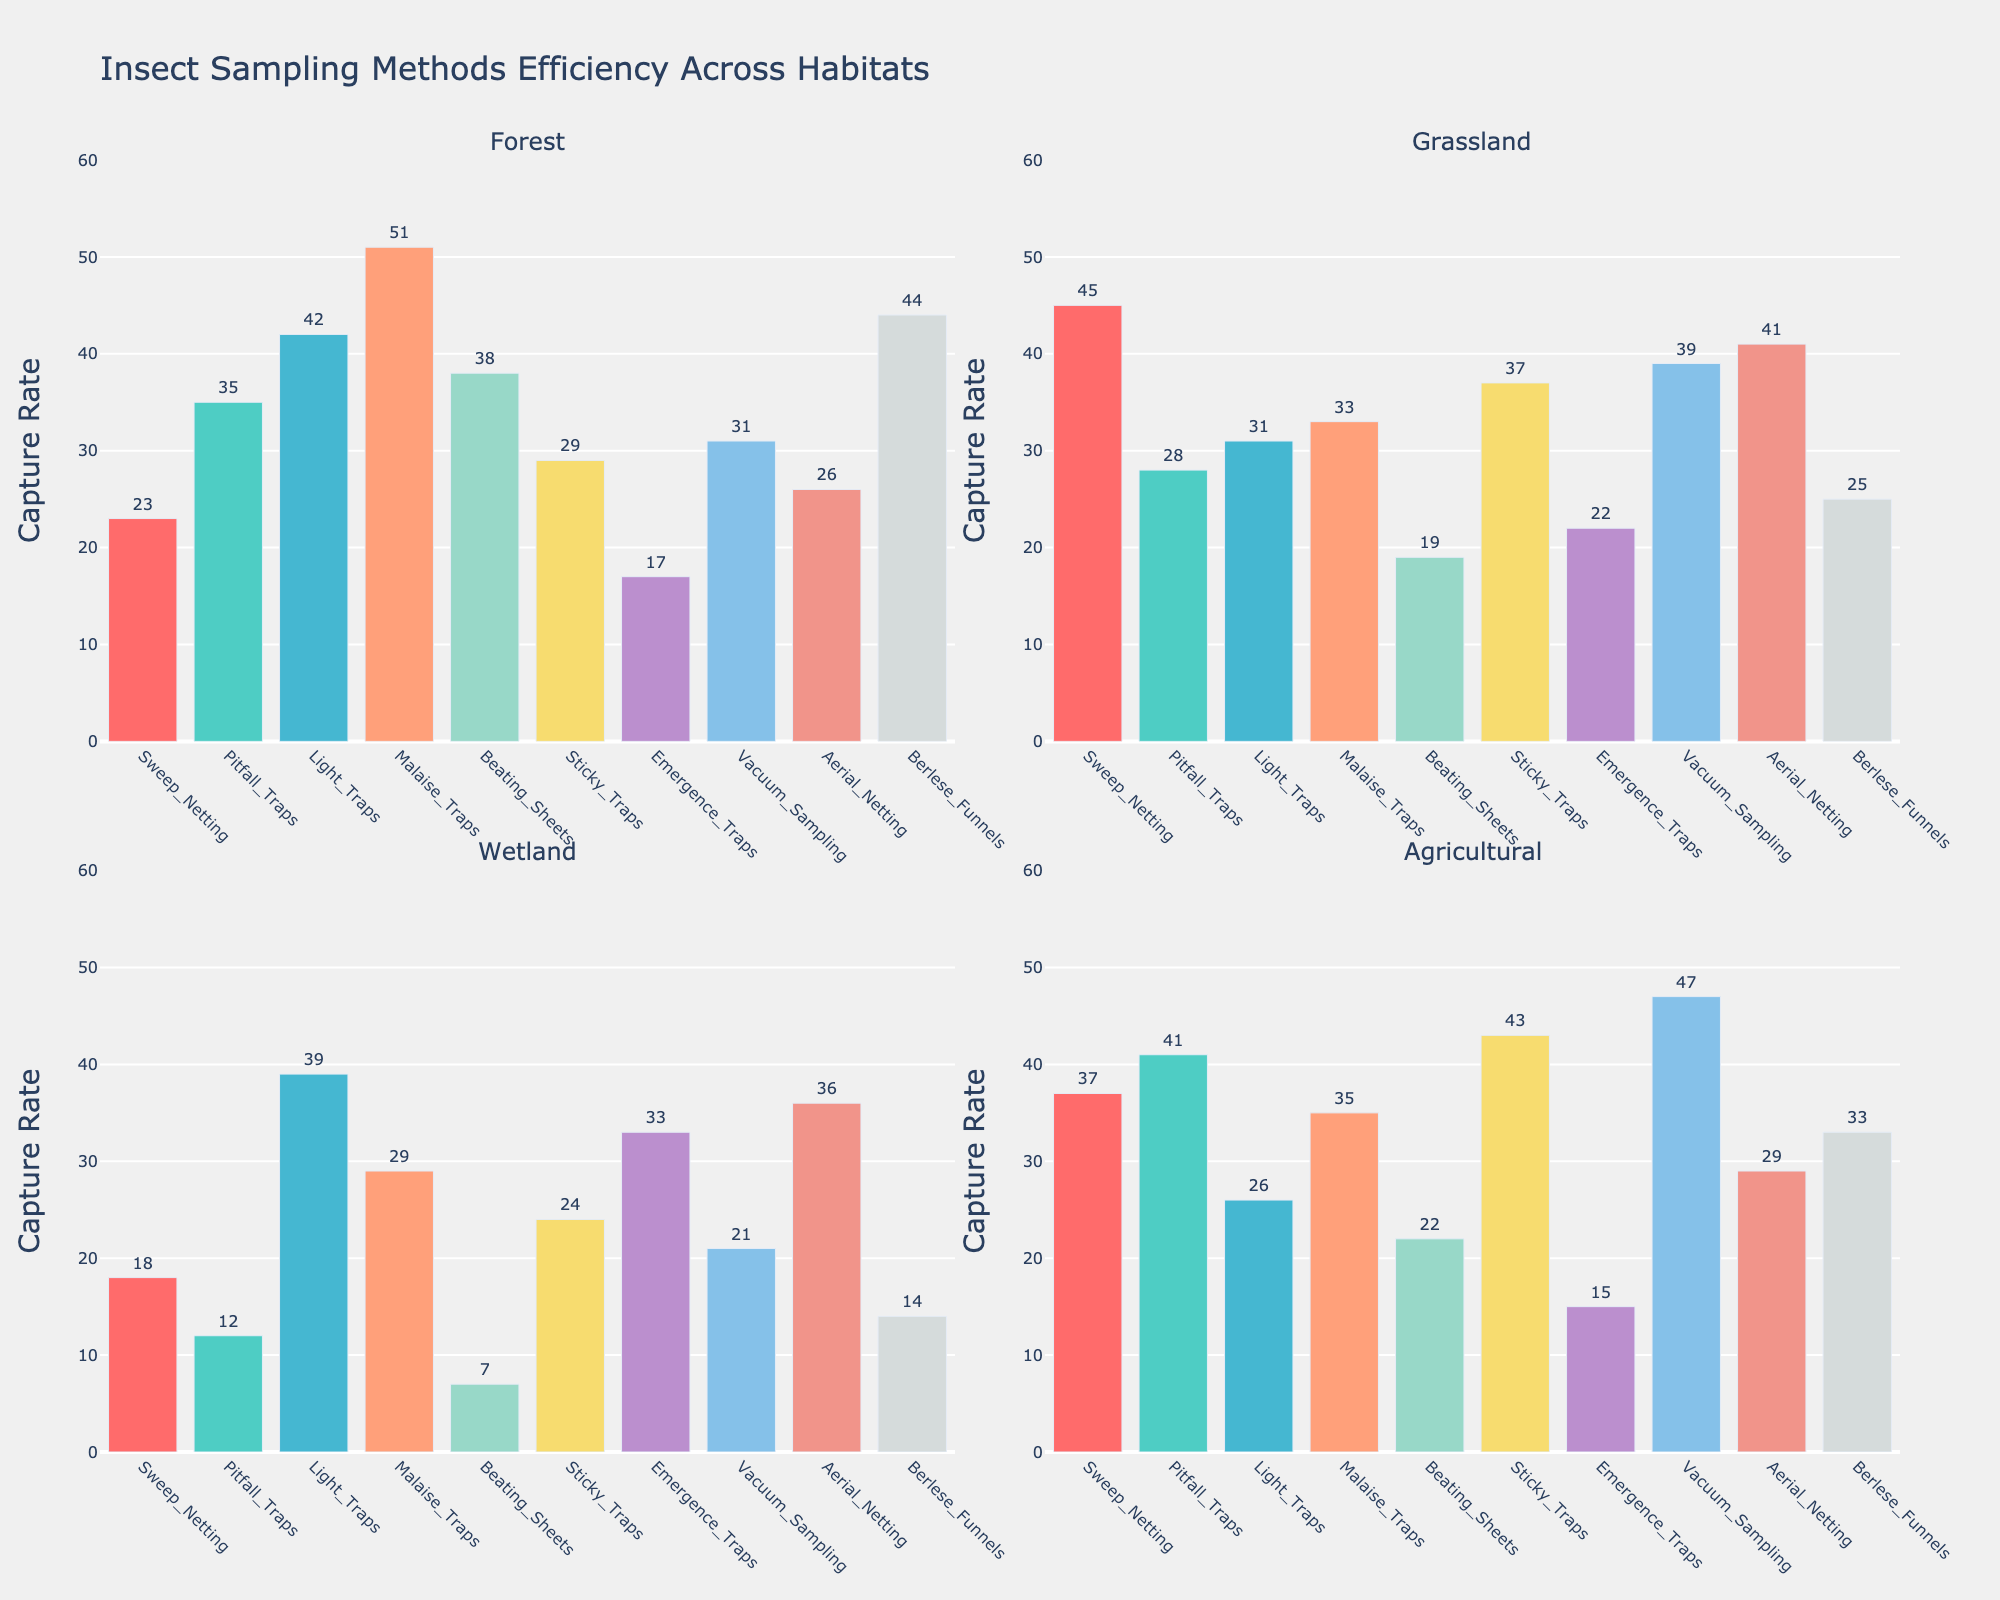What's the average capture rate across all habitats for Light Traps? To find the average capture rate for Light Traps, sum the capture rates for Forest (42), Grassland (31), Wetland (39), and Agricultural (26), then divide by the number of habitats (4). The sum is 138, so the average is 138 / 4.
Answer: 34.5 Which sampling method has the highest capture rate in the Wetland habitat? Look at the bars representing the capture rates in the Wetland habitat subplot. The highest bar corresponds to Light Traps with a capture rate of 39.
Answer: Light Traps Is the capture rate of Beating Sheets in Forest higher or lower than the capture rate of Pitfall Traps in Grassland? Compare the heights of the bars in the Forest subplot for Beating Sheets (38) and the Grassland subplot for Pitfall Traps (28). 38 is higher than 28.
Answer: Higher What's the difference in capture rate between Sweep Netting in Grassland and Beating Sheets in Wetland? Subtract the capture rate of Beating Sheets in Wetland (7) from the capture rate of Sweep Netting in Grassland (45). 45 - 7 = 38.
Answer: 38 Rank the habitats from highest to lowest average capture rate for Sweep Netting. Calculate the average capture rate for Sweep Netting across each habitat. Forest: 23, Grassland: 45, Wetland: 18, Agricultural: 37. Rank them: Grassland (45), Agricultural (37), Forest (23), Wetland (18).
Answer: Grassland, Agricultural, Forest, Wetland Which habitat sees the highest capture rate for Malaise Traps, and what is its value? Check the Malaise Traps' capture rates in each habitat. The highest is in Forest with a value of 51.
Answer: Forest, 51 What is the combined capture rate of Sticky Traps in Grassland and Vacuum Sampling in Agricultural? Add the capture rates of Sticky Traps in Grassland (37) and Vacuum Sampling in Agricultural (47). 37 + 47 = 84.
Answer: 84 Compare the capture rates of Aerial Netting and Pitfall Traps in Agricultural. Which is higher? Look at the bars representing these capture rates in the Agricultural subplot. Aerial Netting is 29 and Pitfall Traps is 41. Thus, Pitfall Traps is higher.
Answer: Pitfall Traps What is the median capture rate of Berlese Funnels methods across the four habitats? List capture rates for Berlese Funnels: 44 (Forest), 25 (Grassland), 14 (Wetland), 33 (Agricultural). Order them: 14, 25, 33, 44. The median is the average of the two middle numbers (25 and 33), so (25 + 33) / 2 = 29.
Answer: 29 Rank the sampling methods from highest to lowest capture rate in Agricultural habitat. List capture rates for Agricultural habitat: Sweep Netting (37), Pitfall Traps (41), Light Traps (26), Malaise Traps (35), Beating Sheets (22), Sticky Traps (43), Emergence Traps (15), Vacuum Sampling (47), Aerial Netting (29), Berlese Funnels (33). Order them: Vacuum Sampling (47), Sticky Traps (43), Pitfall Traps (41), Sweep Netting (37), Malaise Traps (35), Berlese Funnels (33), Aerial Netting (29), Light Traps (26), Beating Sheets (22), Emergence Traps (15).
Answer: Vacuum Sampling, Sticky Traps, Pitfall Traps, Sweep Netting, Malaise Traps, Berlese Funnels, Aerial Netting, Light Traps, Beating Sheets, Emergence Traps 